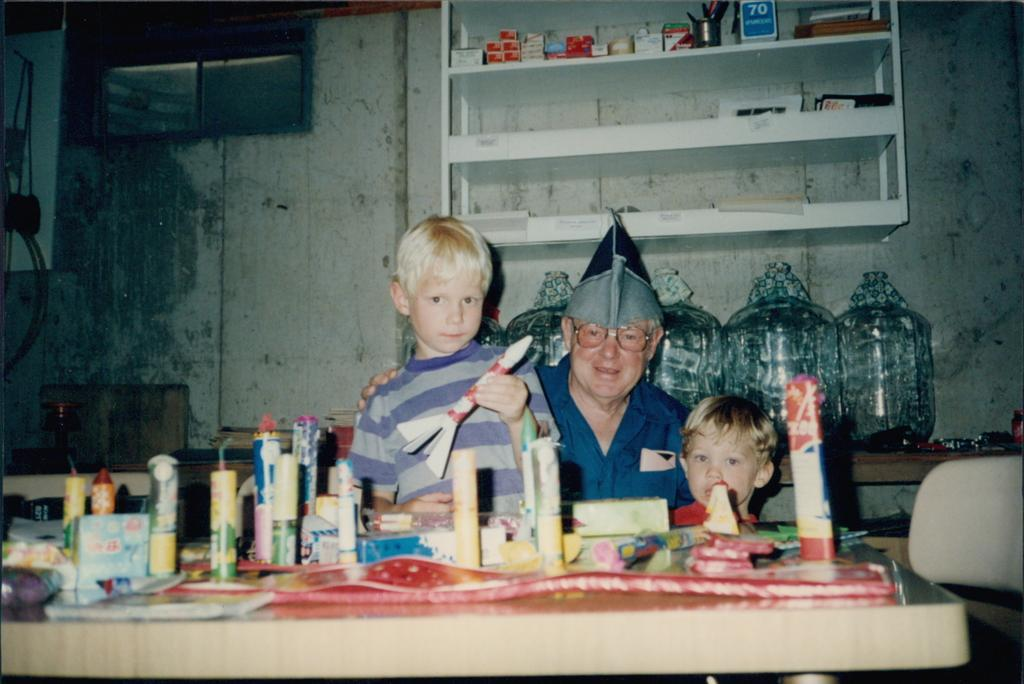What can be seen in the image involving people? There are people standing in the image. What object is present in the image that people might gather around? There is a table in the image. What type of food or snack is visible on the table? Crackers are present on the table. What song is the queen singing in the image? There is no queen or song present in the image. How many train tracks can be seen in the image? There are no train tracks visible in the image. 